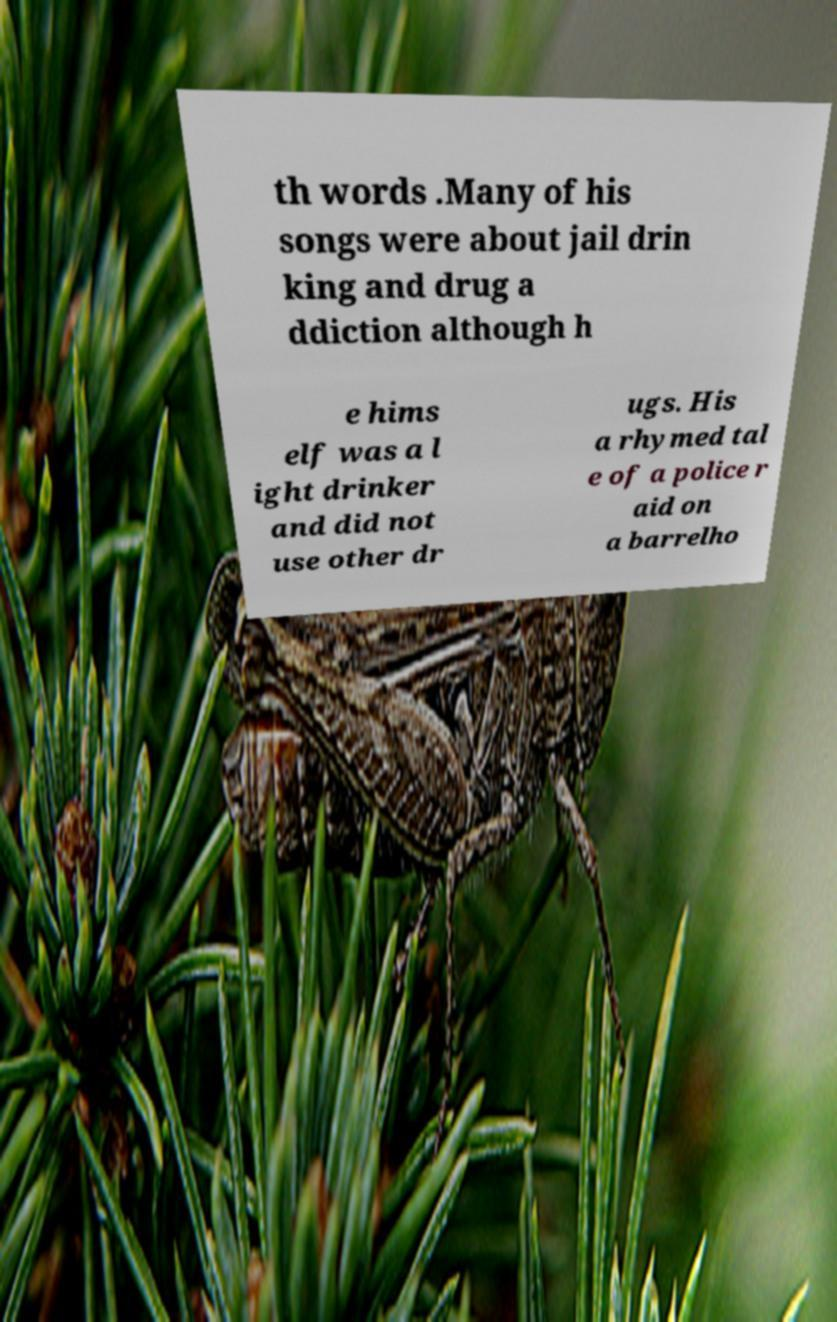For documentation purposes, I need the text within this image transcribed. Could you provide that? th words .Many of his songs were about jail drin king and drug a ddiction although h e hims elf was a l ight drinker and did not use other dr ugs. His a rhymed tal e of a police r aid on a barrelho 